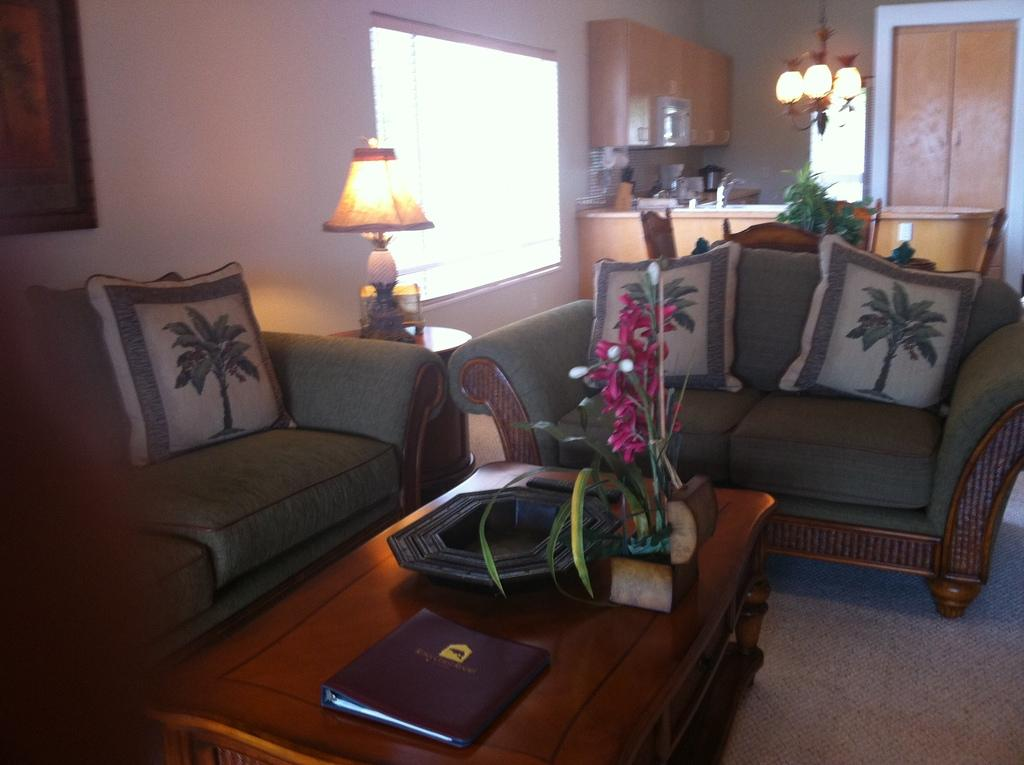Where is the setting of the image? The image is inside a room. What type of furniture is present in the room? There is a sofa with pillows and a dining table with chairs in the room. Are there any decorative items in the room? Yes, there is a flower vase and a photo frame on the wall in the room. What objects might be used for work or organization? There is a file in the room. What type of lighting is available in the room? There is a lamp and lights in the room. Can you see a truck in the image? No, there is no truck present in the image. 